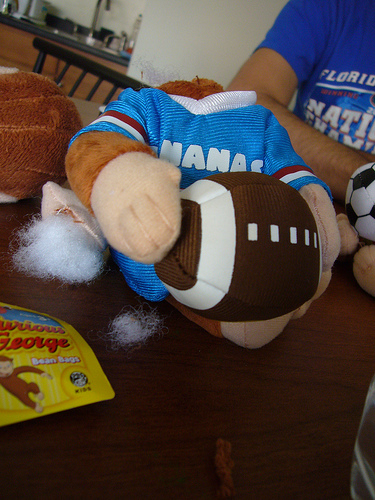<image>
Can you confirm if the football is under the monkey? No. The football is not positioned under the monkey. The vertical relationship between these objects is different. 